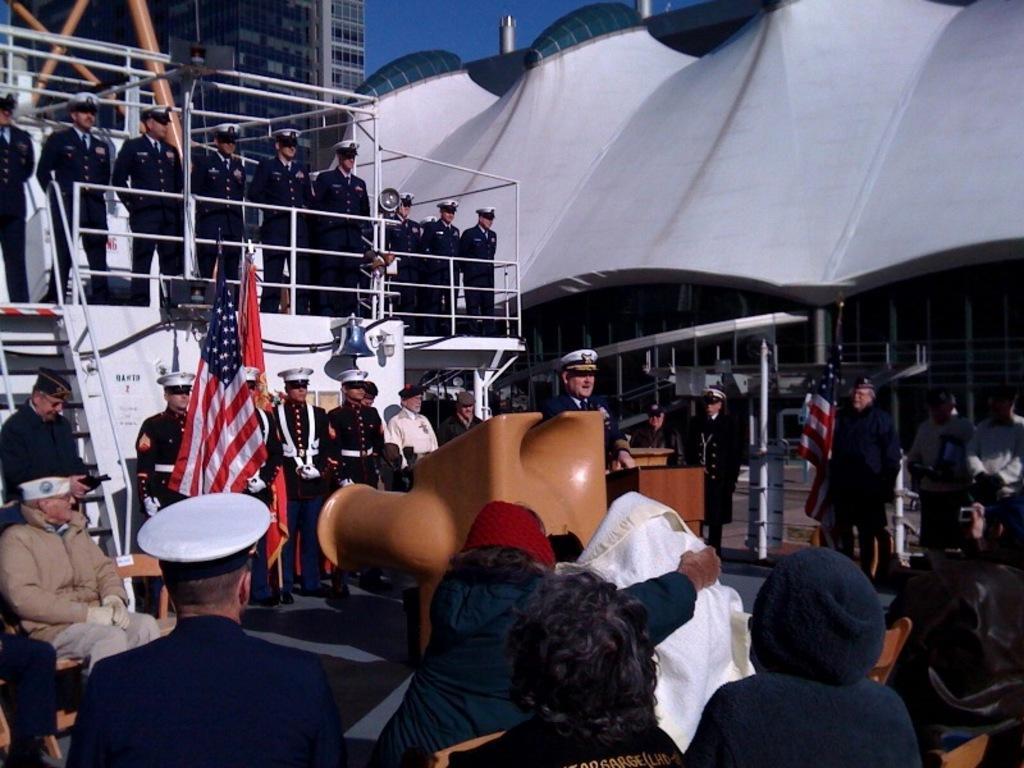In one or two sentences, can you explain what this image depicts? In this image we can see a group of people standing on the ground, some people are wearing caps. In the center of the image we can see some flags, at podium, a bell and the lamp on the wall. On the left side of the image we can see staircase, railing. In the foreground of the image we can see some people sitting on chairs. In the background, we can see buildings, poles and the sky. 